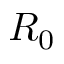<formula> <loc_0><loc_0><loc_500><loc_500>R _ { 0 }</formula> 